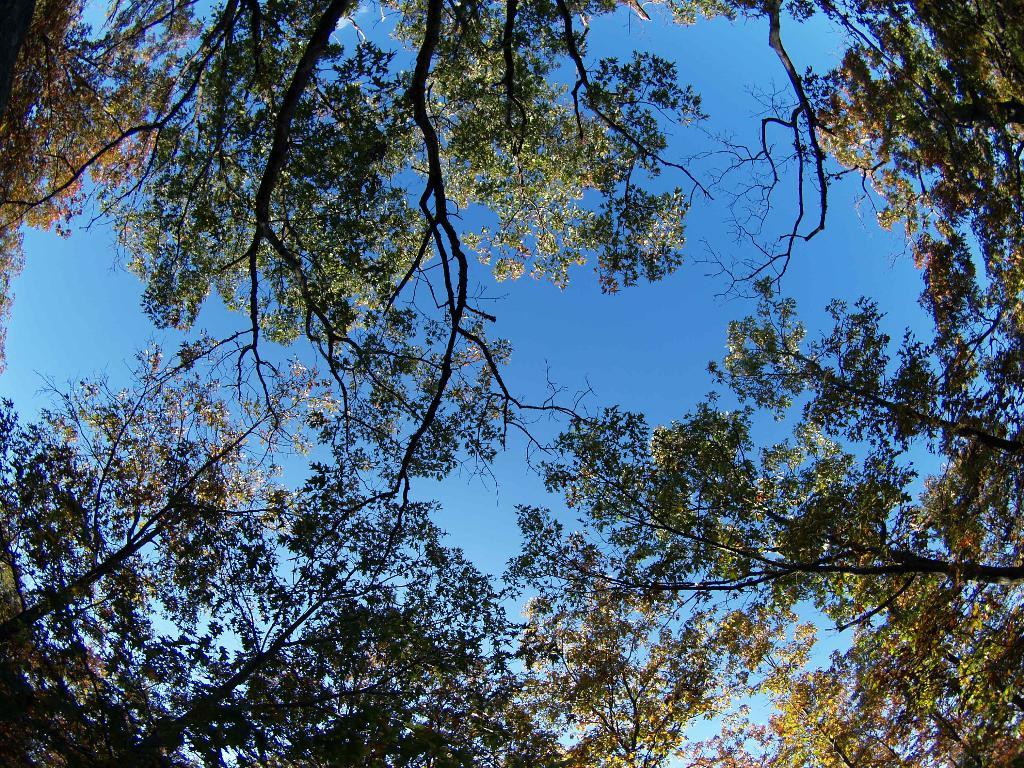What type of vegetation can be seen in the image? There are trees visible in the image. What is visible at the top of the image? The sky is visible at the top of the image. How many quills can be seen in the image? There are no quills present in the image. What type of frog can be seen in the image? There are no frogs present in the image. 